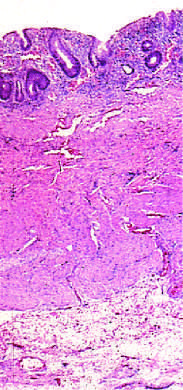what does this full-thickness histologic section show?
Answer the question using a single word or phrase. Disease is limited to the mucosa 